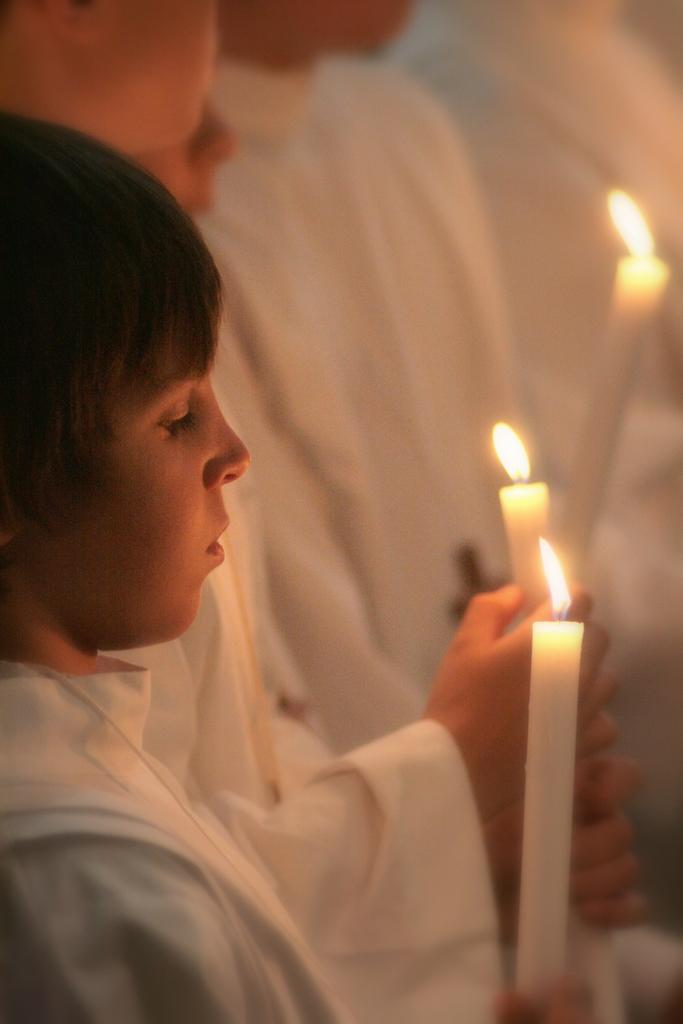How many people are in the image? There are people in the image, but the exact number is not specified. What are the people doing in the image? The people are standing in the image. What objects are the people holding in the image? The people are holding candles in the image. What type of education do the fairies in the image have? There are no fairies present in the image, so it is not possible to determine their education. 